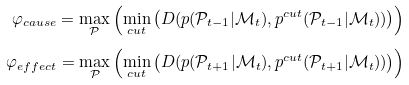<formula> <loc_0><loc_0><loc_500><loc_500>\varphi _ { c a u s e } = \underset { \mathcal { P } } { \max } \left ( \underset { c u t } { \min } \left ( D ( p ( \mathcal { P } _ { t - 1 } | \mathcal { M } _ { t } ) , p ^ { c u t } ( \mathcal { P } _ { t - 1 } | \mathcal { M } _ { t } ) ) \right ) \right ) \\ \varphi _ { e f f e c t } = \underset { \mathcal { P } } { \max } \left ( \underset { c u t } { \min } \left ( D ( p ( \mathcal { P } _ { t + 1 } | \mathcal { M } _ { t } ) , p ^ { c u t } ( \mathcal { P } _ { t + 1 } | \mathcal { M } _ { t } ) ) \right ) \right )</formula> 